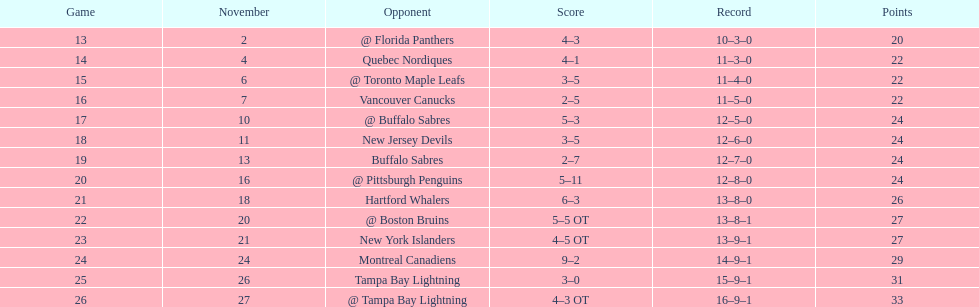Could you parse the entire table as a dict? {'header': ['Game', 'November', 'Opponent', 'Score', 'Record', 'Points'], 'rows': [['13', '2', '@ Florida Panthers', '4–3', '10–3–0', '20'], ['14', '4', 'Quebec Nordiques', '4–1', '11–3–0', '22'], ['15', '6', '@ Toronto Maple Leafs', '3–5', '11–4–0', '22'], ['16', '7', 'Vancouver Canucks', '2–5', '11–5–0', '22'], ['17', '10', '@ Buffalo Sabres', '5–3', '12–5–0', '24'], ['18', '11', 'New Jersey Devils', '3–5', '12–6–0', '24'], ['19', '13', 'Buffalo Sabres', '2–7', '12–7–0', '24'], ['20', '16', '@ Pittsburgh Penguins', '5–11', '12–8–0', '24'], ['21', '18', 'Hartford Whalers', '6–3', '13–8–0', '26'], ['22', '20', '@ Boston Bruins', '5–5 OT', '13–8–1', '27'], ['23', '21', 'New York Islanders', '4–5 OT', '13–9–1', '27'], ['24', '24', 'Montreal Canadiens', '9–2', '14–9–1', '29'], ['25', '26', 'Tampa Bay Lightning', '3–0', '15–9–1', '31'], ['26', '27', '@ Tampa Bay Lightning', '4–3 OT', '16–9–1', '33']]} Up to the 1993-1994 season, how many seasons in a row did the flyers miss playoff appearances? 5. 